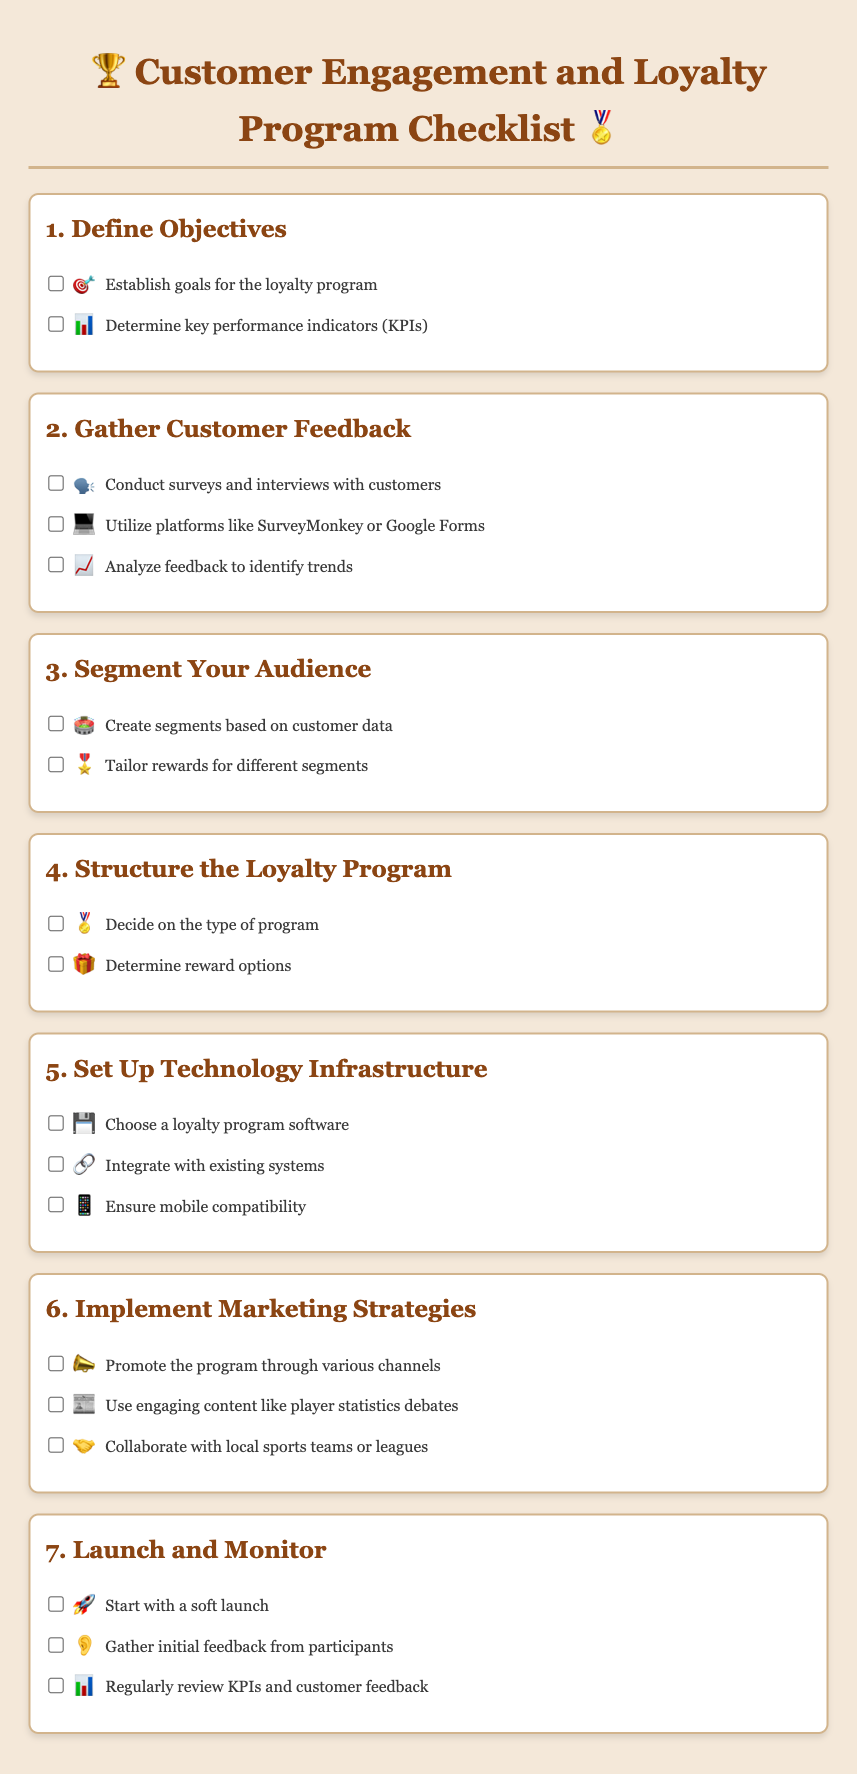what is the title of the document? The title is indicated at the top of the rendered document.
Answer: Customer Engagement and Loyalty Program Checklist how many main sections are in the document? The number of main sections can be counted in the document.
Answer: 7 which icon represents gathering customer feedback? The icon is associated with the section about gathering customer feedback.
Answer: 🗣️ what is one of the activities to gather customer feedback? The activity is listed under the "Gather Customer Feedback" section.
Answer: Conduct surveys and interviews with customers what should be included in the technology infrastructure setup? The items listed in the technology setup section will specify what's included.
Answer: Choose a loyalty program software what is a type of marketing strategy mentioned? The marketing strategies provided under their section detail the required strategies.
Answer: Promote the program through various channels how often should customer feedback be reviewed? This is described in the "Launch and Monitor" section regarding feedback review frequency.
Answer: Regularly 